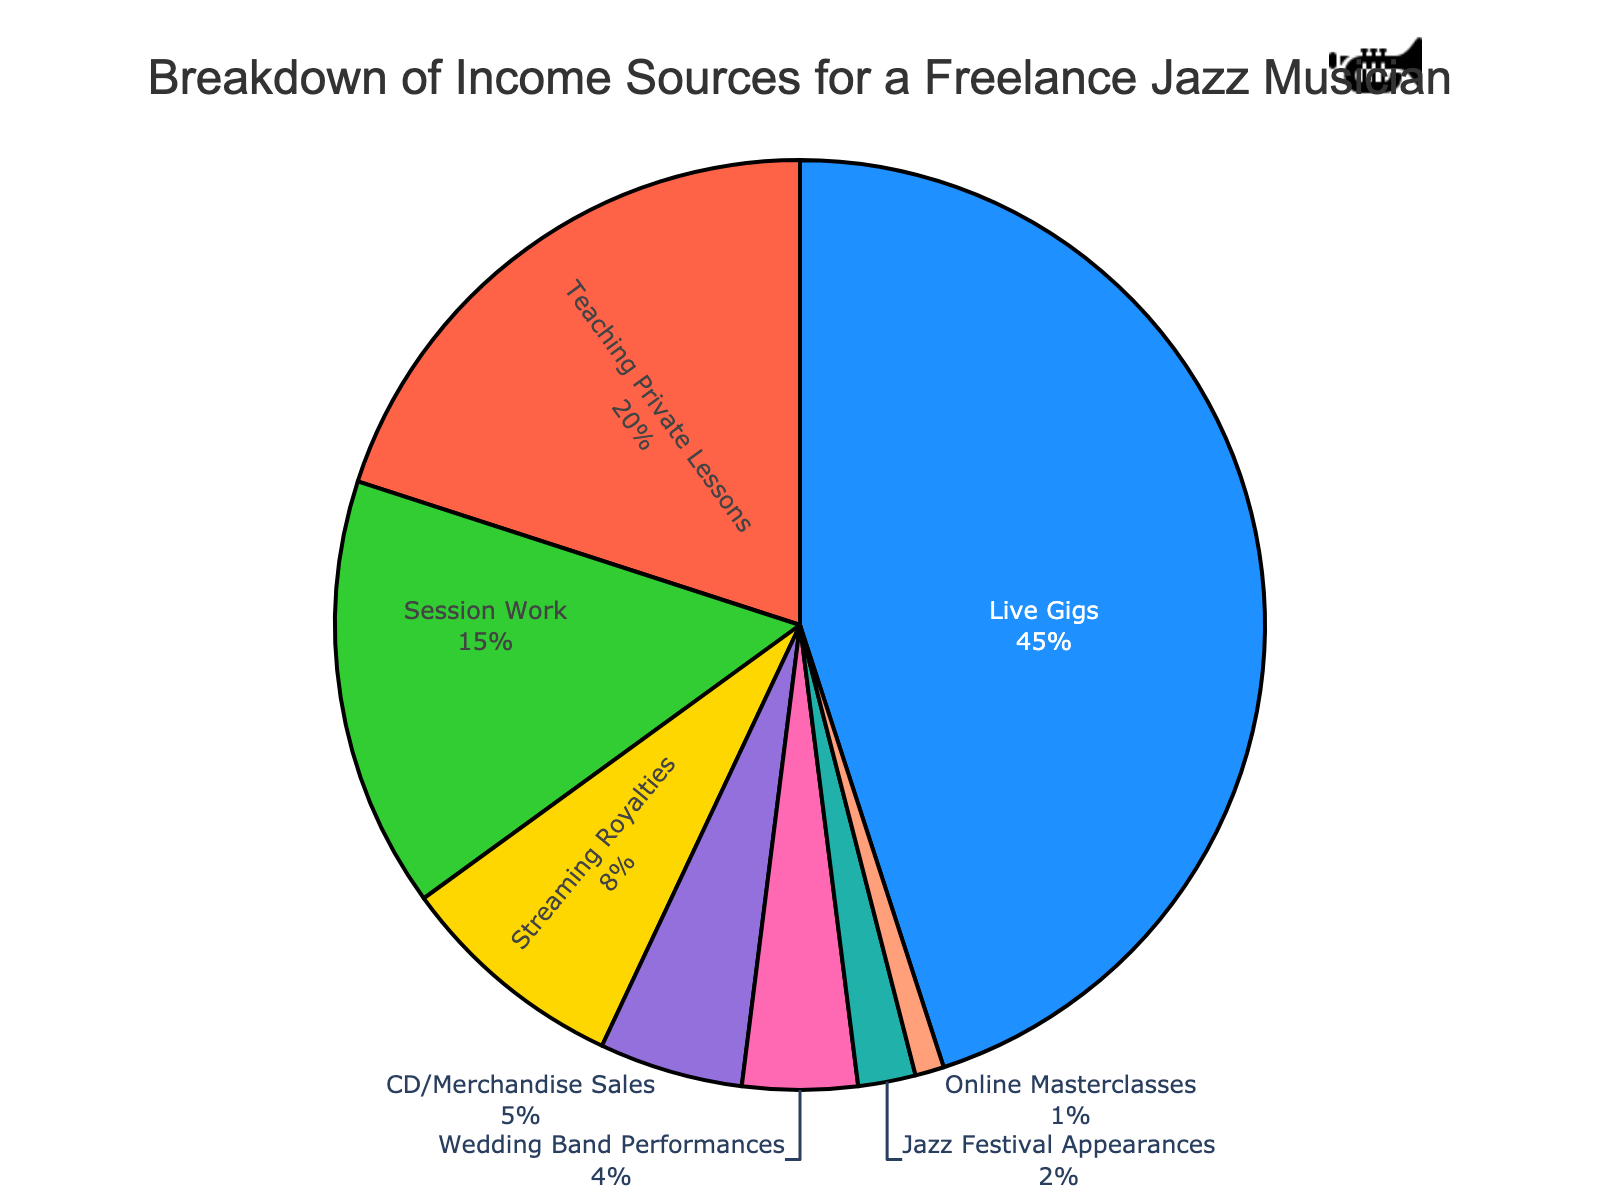What is the largest source of income for the freelance jazz musician? The largest segment in the pie chart represents Live Gigs, which occupies 45% of the total income.
Answer: Live Gigs What is the combined percentage of income from Teaching Private Lessons and Session Work? Teaching Private Lessons accounts for 20% and Session Work accounts for 15%. Adding these together, 20% + 15% = 35%.
Answer: 35% Which income source contributes less: Streaming Royalties or Wedding Band Performances? Streaming Royalties contribute 8% while Wedding Band Performances contribute 4%. Since 4% is less than 8%, Wedding Band Performances contribute less.
Answer: Wedding Band Performances What is the difference in percentage between the income from CD/Merchandise Sales and Jazz Festival Appearances? CD/Merchandise Sales contribute 5%, while Jazz Festival Appearances contribute 2%. The difference is 5% - 2% = 3%.
Answer: 3% How much more does Live Gigs contribute to the income compared to Streaming Royalties? Live Gigs contribute 45%, and Streaming Royalties contribute 8%. The difference is 45% - 8% = 37%.
Answer: 37% Which income source has the smallest contribution and what is its percentage? The smallest segment in the pie chart is Online Masterclasses, which occupies 1% of the total income.
Answer: Online Masterclasses Is the percentage of income from Teaching Private Lessons more than double that from CD/Merchandise Sales? Teaching Private Lessons accounts for 20%, while CD/Merchandise Sales account for 5%. Twice the percentage of CD/Merchandise Sales is 2 * 5% = 10%. Since 20% is greater than 10%, Teaching Private Lessons is indeed more than double.
Answer: Yes Does the combined income from Wedding Band Performances and Jazz Festival Appearances exceed 5% of the total income? Wedding Band Performances contribute 4%, and Jazz Festival Appearances contribute 2%. Combined, they contribute 4% + 2% = 6%. Since 6% exceeds 5%, the combined percentage does indeed exceed 5%.
Answer: Yes How many income sources contribute less than 10% to the total income? The income sources contributing less than 10% are Streaming Royalties (8%), CD/Merchandise Sales (5%), Wedding Band Performances (4%), Jazz Festival Appearances (2%), and Online Masterclasses (1%). This makes a total of 5 income sources.
Answer: 5 What is the total percentage of income from sources that contribute more than 10%? The sources that contribute more than 10% are Live Gigs (45%), Teaching Private Lessons (20%), and Session Work (15%). Adding these together, 45% + 20% + 15% = 80%.
Answer: 80% 